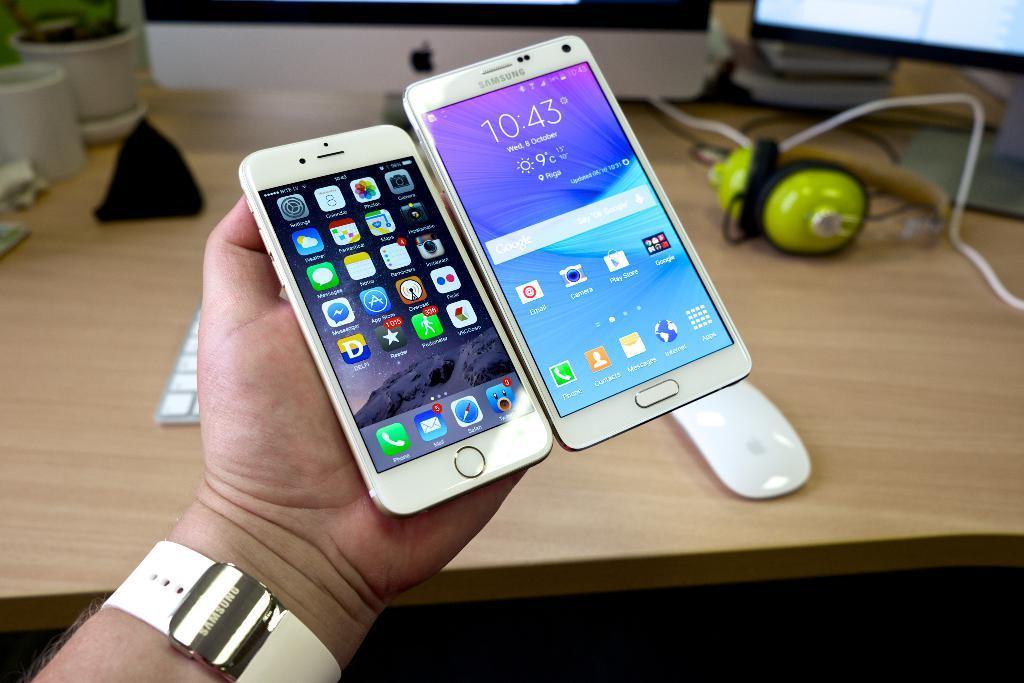Please provide a concise description of this image. In the picture we can see a person's hand holding two mobile phones and under the hand we can see a part of the desk with headsets, mouse, a part of the monitor and the keyboard. 